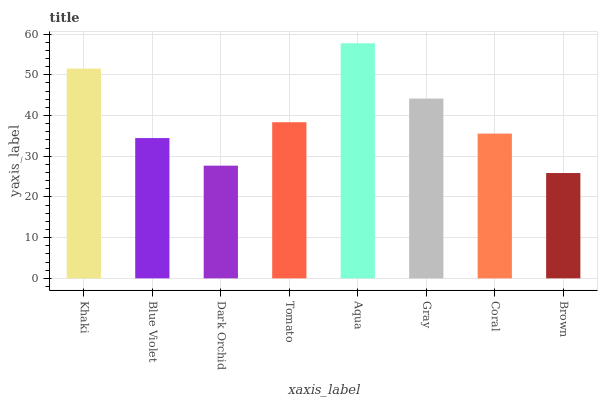Is Brown the minimum?
Answer yes or no. Yes. Is Aqua the maximum?
Answer yes or no. Yes. Is Blue Violet the minimum?
Answer yes or no. No. Is Blue Violet the maximum?
Answer yes or no. No. Is Khaki greater than Blue Violet?
Answer yes or no. Yes. Is Blue Violet less than Khaki?
Answer yes or no. Yes. Is Blue Violet greater than Khaki?
Answer yes or no. No. Is Khaki less than Blue Violet?
Answer yes or no. No. Is Tomato the high median?
Answer yes or no. Yes. Is Coral the low median?
Answer yes or no. Yes. Is Dark Orchid the high median?
Answer yes or no. No. Is Aqua the low median?
Answer yes or no. No. 